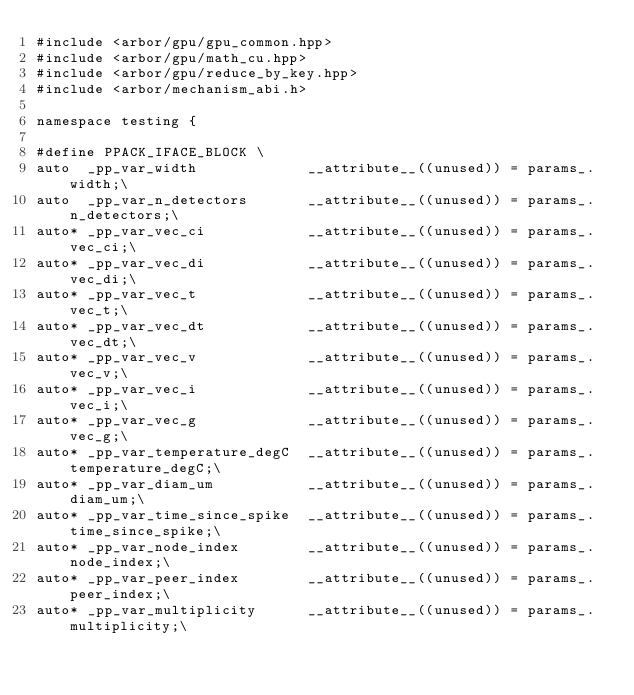<code> <loc_0><loc_0><loc_500><loc_500><_Cuda_>#include <arbor/gpu/gpu_common.hpp>
#include <arbor/gpu/math_cu.hpp>
#include <arbor/gpu/reduce_by_key.hpp>
#include <arbor/mechanism_abi.h>

namespace testing {

#define PPACK_IFACE_BLOCK \
auto  _pp_var_width             __attribute__((unused)) = params_.width;\
auto  _pp_var_n_detectors       __attribute__((unused)) = params_.n_detectors;\
auto* _pp_var_vec_ci            __attribute__((unused)) = params_.vec_ci;\
auto* _pp_var_vec_di            __attribute__((unused)) = params_.vec_di;\
auto* _pp_var_vec_t             __attribute__((unused)) = params_.vec_t;\
auto* _pp_var_vec_dt            __attribute__((unused)) = params_.vec_dt;\
auto* _pp_var_vec_v             __attribute__((unused)) = params_.vec_v;\
auto* _pp_var_vec_i             __attribute__((unused)) = params_.vec_i;\
auto* _pp_var_vec_g             __attribute__((unused)) = params_.vec_g;\
auto* _pp_var_temperature_degC  __attribute__((unused)) = params_.temperature_degC;\
auto* _pp_var_diam_um           __attribute__((unused)) = params_.diam_um;\
auto* _pp_var_time_since_spike  __attribute__((unused)) = params_.time_since_spike;\
auto* _pp_var_node_index        __attribute__((unused)) = params_.node_index;\
auto* _pp_var_peer_index        __attribute__((unused)) = params_.peer_index;\
auto* _pp_var_multiplicity      __attribute__((unused)) = params_.multiplicity;\</code> 